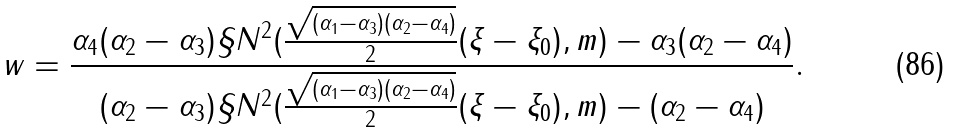Convert formula to latex. <formula><loc_0><loc_0><loc_500><loc_500>w = \frac { \alpha _ { 4 } ( \alpha _ { 2 } - \alpha _ { 3 } ) \S N ^ { 2 } { ( \frac { \sqrt { ( \alpha _ { 1 } - \alpha _ { 3 } ) ( \alpha _ { 2 } - \alpha _ { 4 } ) } } { 2 } ( \xi - \xi _ { 0 } ) , m ) - \alpha _ { 3 } ( \alpha _ { 2 } - \alpha _ { 4 } ) } } { ( \alpha _ { 2 } - \alpha _ { 3 } ) \S N ^ { 2 } { ( \frac { \sqrt { ( \alpha _ { 1 } - \alpha _ { 3 } ) ( \alpha _ { 2 } - \alpha _ { 4 } ) } } { 2 } ( \xi - \xi _ { 0 } ) , m ) - ( \alpha _ { 2 } - \alpha _ { 4 } ) } } .</formula> 